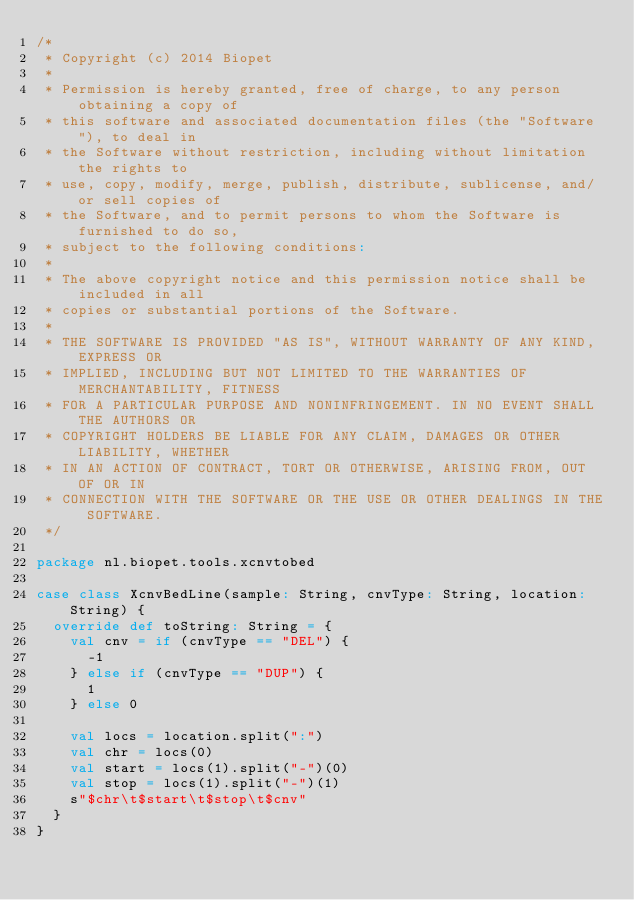<code> <loc_0><loc_0><loc_500><loc_500><_Scala_>/*
 * Copyright (c) 2014 Biopet
 *
 * Permission is hereby granted, free of charge, to any person obtaining a copy of
 * this software and associated documentation files (the "Software"), to deal in
 * the Software without restriction, including without limitation the rights to
 * use, copy, modify, merge, publish, distribute, sublicense, and/or sell copies of
 * the Software, and to permit persons to whom the Software is furnished to do so,
 * subject to the following conditions:
 *
 * The above copyright notice and this permission notice shall be included in all
 * copies or substantial portions of the Software.
 *
 * THE SOFTWARE IS PROVIDED "AS IS", WITHOUT WARRANTY OF ANY KIND, EXPRESS OR
 * IMPLIED, INCLUDING BUT NOT LIMITED TO THE WARRANTIES OF MERCHANTABILITY, FITNESS
 * FOR A PARTICULAR PURPOSE AND NONINFRINGEMENT. IN NO EVENT SHALL THE AUTHORS OR
 * COPYRIGHT HOLDERS BE LIABLE FOR ANY CLAIM, DAMAGES OR OTHER LIABILITY, WHETHER
 * IN AN ACTION OF CONTRACT, TORT OR OTHERWISE, ARISING FROM, OUT OF OR IN
 * CONNECTION WITH THE SOFTWARE OR THE USE OR OTHER DEALINGS IN THE SOFTWARE.
 */

package nl.biopet.tools.xcnvtobed

case class XcnvBedLine(sample: String, cnvType: String, location: String) {
  override def toString: String = {
    val cnv = if (cnvType == "DEL") {
      -1
    } else if (cnvType == "DUP") {
      1
    } else 0

    val locs = location.split(":")
    val chr = locs(0)
    val start = locs(1).split("-")(0)
    val stop = locs(1).split("-")(1)
    s"$chr\t$start\t$stop\t$cnv"
  }
}
</code> 